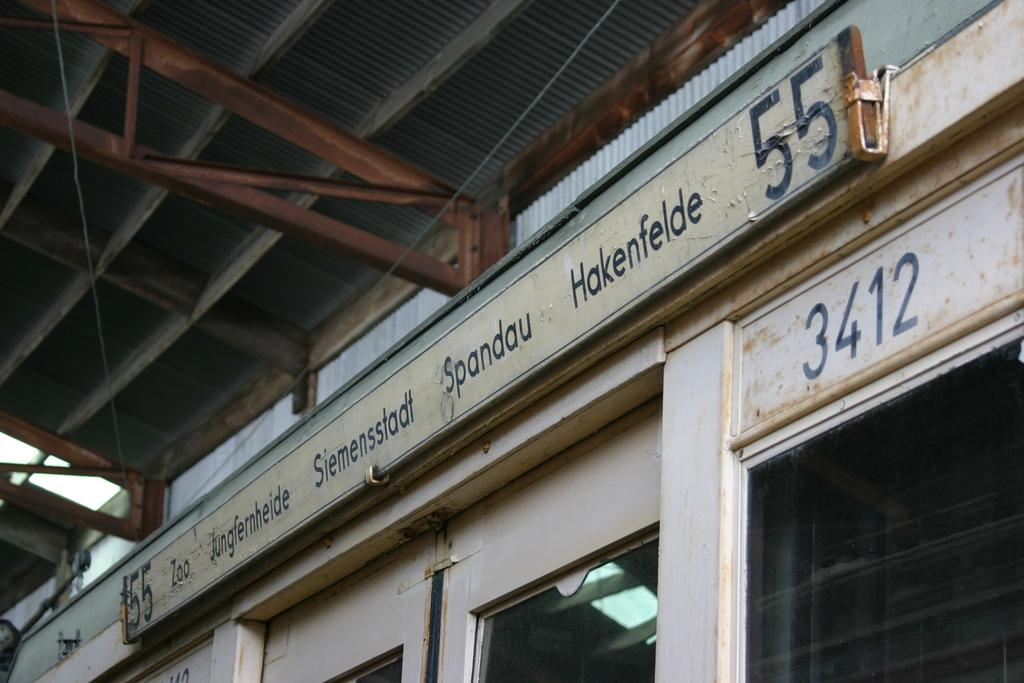What type of establishment is visible in the image? There is a small shop in the image. How can the name of the shop be identified? The shop has a naming board. What structure is present above the shop? There is a metal frame shed above the shop. Reasoning: Let' Let's think step by step in order to produce the conversation. We start by identifying the main subject in the image, which is the small shop. Then, we expand the conversation to include other details about the shop, such as the naming board and the metal frame shed. Each question is designed to elicit a specific detail about the image that is known from the provided facts. Absurd Question/Answer: Can you see any shoes hanging from the moon in the image? There is no moon visible in the image, nor are there any shoes hanging from it. 